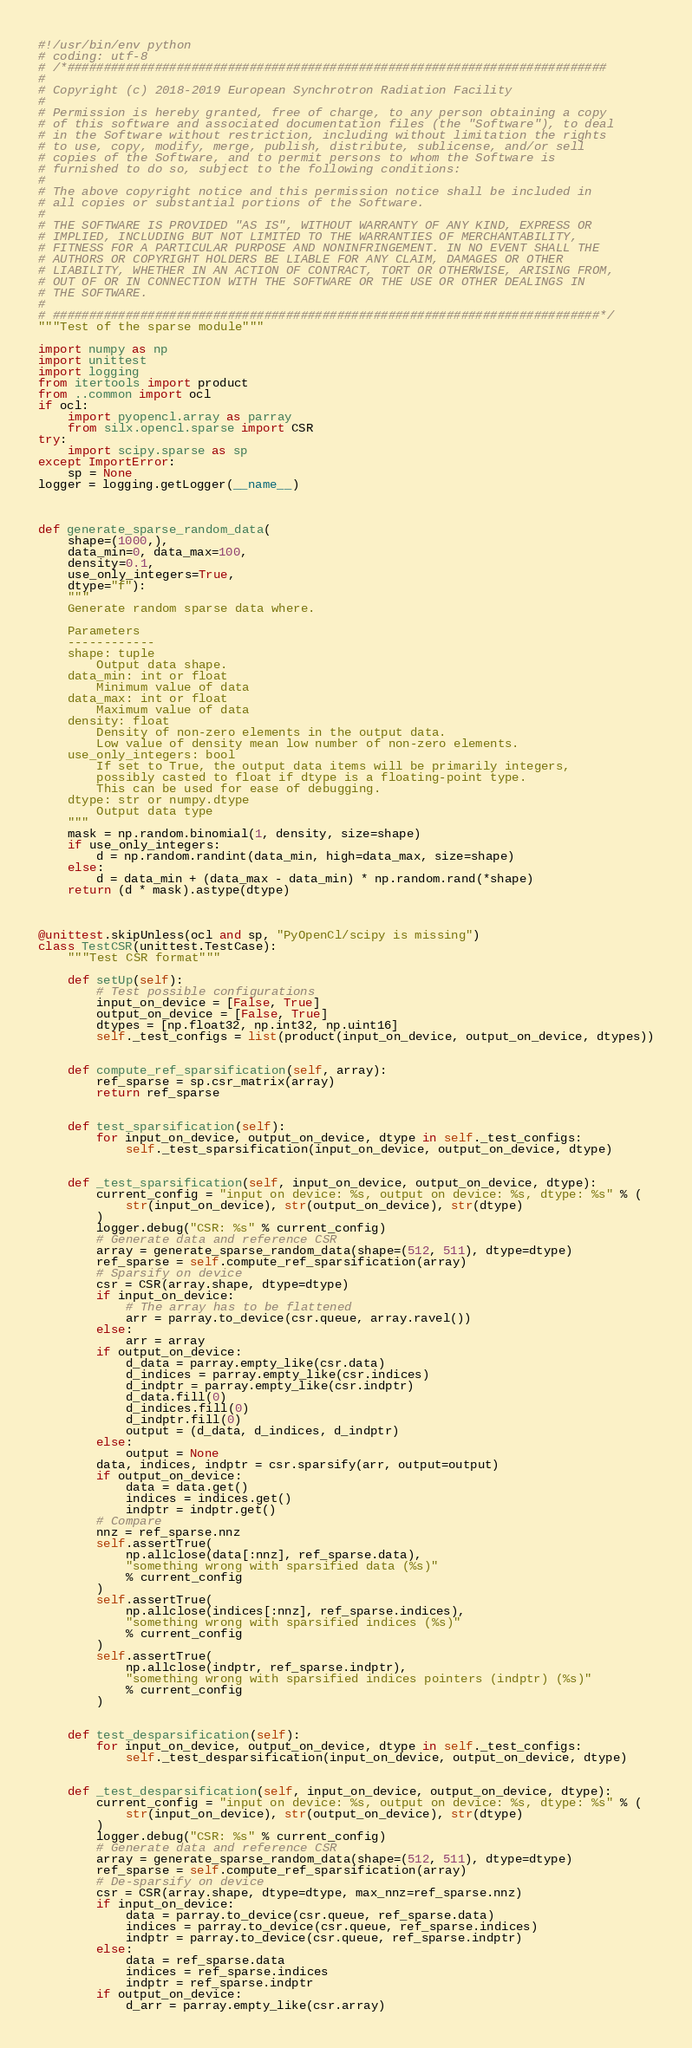Convert code to text. <code><loc_0><loc_0><loc_500><loc_500><_Python_>#!/usr/bin/env python
# coding: utf-8
# /*##########################################################################
#
# Copyright (c) 2018-2019 European Synchrotron Radiation Facility
#
# Permission is hereby granted, free of charge, to any person obtaining a copy
# of this software and associated documentation files (the "Software"), to deal
# in the Software without restriction, including without limitation the rights
# to use, copy, modify, merge, publish, distribute, sublicense, and/or sell
# copies of the Software, and to permit persons to whom the Software is
# furnished to do so, subject to the following conditions:
#
# The above copyright notice and this permission notice shall be included in
# all copies or substantial portions of the Software.
#
# THE SOFTWARE IS PROVIDED "AS IS", WITHOUT WARRANTY OF ANY KIND, EXPRESS OR
# IMPLIED, INCLUDING BUT NOT LIMITED TO THE WARRANTIES OF MERCHANTABILITY,
# FITNESS FOR A PARTICULAR PURPOSE AND NONINFRINGEMENT. IN NO EVENT SHALL THE
# AUTHORS OR COPYRIGHT HOLDERS BE LIABLE FOR ANY CLAIM, DAMAGES OR OTHER
# LIABILITY, WHETHER IN AN ACTION OF CONTRACT, TORT OR OTHERWISE, ARISING FROM,
# OUT OF OR IN CONNECTION WITH THE SOFTWARE OR THE USE OR OTHER DEALINGS IN
# THE SOFTWARE.
#
# ###########################################################################*/
"""Test of the sparse module"""

import numpy as np
import unittest
import logging
from itertools import product
from ..common import ocl
if ocl:
    import pyopencl.array as parray
    from silx.opencl.sparse import CSR
try:
    import scipy.sparse as sp
except ImportError:
    sp = None
logger = logging.getLogger(__name__)



def generate_sparse_random_data(
    shape=(1000,),
    data_min=0, data_max=100,
    density=0.1,
    use_only_integers=True,
    dtype="f"):
    """
    Generate random sparse data where.

    Parameters
    ------------
    shape: tuple
        Output data shape.
    data_min: int or float
        Minimum value of data
    data_max: int or float
        Maximum value of data
    density: float
        Density of non-zero elements in the output data.
        Low value of density mean low number of non-zero elements.
    use_only_integers: bool
        If set to True, the output data items will be primarily integers,
        possibly casted to float if dtype is a floating-point type.
        This can be used for ease of debugging.
    dtype: str or numpy.dtype
        Output data type
    """
    mask = np.random.binomial(1, density, size=shape)
    if use_only_integers:
        d = np.random.randint(data_min, high=data_max, size=shape)
    else:
        d = data_min + (data_max - data_min) * np.random.rand(*shape)
    return (d * mask).astype(dtype)



@unittest.skipUnless(ocl and sp, "PyOpenCl/scipy is missing")
class TestCSR(unittest.TestCase):
    """Test CSR format"""

    def setUp(self):
        # Test possible configurations
        input_on_device = [False, True]
        output_on_device = [False, True]
        dtypes = [np.float32, np.int32, np.uint16]
        self._test_configs = list(product(input_on_device, output_on_device, dtypes))


    def compute_ref_sparsification(self, array):
        ref_sparse = sp.csr_matrix(array)
        return ref_sparse


    def test_sparsification(self):
        for input_on_device, output_on_device, dtype in self._test_configs:
            self._test_sparsification(input_on_device, output_on_device, dtype)


    def _test_sparsification(self, input_on_device, output_on_device, dtype):
        current_config = "input on device: %s, output on device: %s, dtype: %s" % (
            str(input_on_device), str(output_on_device), str(dtype)
        )
        logger.debug("CSR: %s" % current_config)
        # Generate data and reference CSR
        array = generate_sparse_random_data(shape=(512, 511), dtype=dtype)
        ref_sparse = self.compute_ref_sparsification(array)
        # Sparsify on device
        csr = CSR(array.shape, dtype=dtype)
        if input_on_device:
            # The array has to be flattened
            arr = parray.to_device(csr.queue, array.ravel())
        else:
            arr = array
        if output_on_device:
            d_data = parray.empty_like(csr.data)
            d_indices = parray.empty_like(csr.indices)
            d_indptr = parray.empty_like(csr.indptr)
            d_data.fill(0)
            d_indices.fill(0)
            d_indptr.fill(0)
            output = (d_data, d_indices, d_indptr)
        else:
            output = None
        data, indices, indptr = csr.sparsify(arr, output=output)
        if output_on_device:
            data = data.get()
            indices = indices.get()
            indptr = indptr.get()
        # Compare
        nnz = ref_sparse.nnz
        self.assertTrue(
            np.allclose(data[:nnz], ref_sparse.data),
            "something wrong with sparsified data (%s)"
            % current_config
        )
        self.assertTrue(
            np.allclose(indices[:nnz], ref_sparse.indices),
            "something wrong with sparsified indices (%s)"
            % current_config
        )
        self.assertTrue(
            np.allclose(indptr, ref_sparse.indptr),
            "something wrong with sparsified indices pointers (indptr) (%s)"
            % current_config
        )


    def test_desparsification(self):
        for input_on_device, output_on_device, dtype in self._test_configs:
            self._test_desparsification(input_on_device, output_on_device, dtype)


    def _test_desparsification(self, input_on_device, output_on_device, dtype):
        current_config = "input on device: %s, output on device: %s, dtype: %s" % (
            str(input_on_device), str(output_on_device), str(dtype)
        )
        logger.debug("CSR: %s" % current_config)
        # Generate data and reference CSR
        array = generate_sparse_random_data(shape=(512, 511), dtype=dtype)
        ref_sparse = self.compute_ref_sparsification(array)
        # De-sparsify on device
        csr = CSR(array.shape, dtype=dtype, max_nnz=ref_sparse.nnz)
        if input_on_device:
            data = parray.to_device(csr.queue, ref_sparse.data)
            indices = parray.to_device(csr.queue, ref_sparse.indices)
            indptr = parray.to_device(csr.queue, ref_sparse.indptr)
        else:
            data = ref_sparse.data
            indices = ref_sparse.indices
            indptr = ref_sparse.indptr
        if output_on_device:
            d_arr = parray.empty_like(csr.array)</code> 